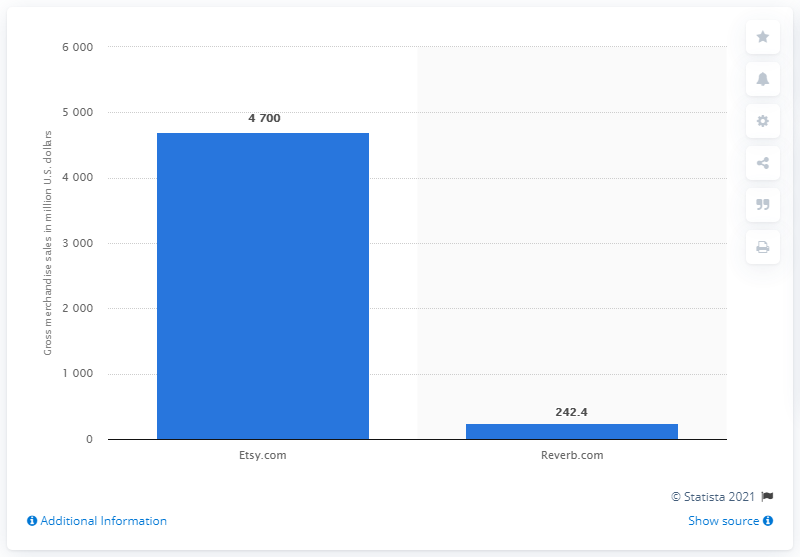List a handful of essential elements in this visual. In 2019, Etsy.com generated approximately $4,700 in gross merchandise sales. In 2019, Reverb.com generated $242.4 million in Gross Merchandise Sales (GMS). 